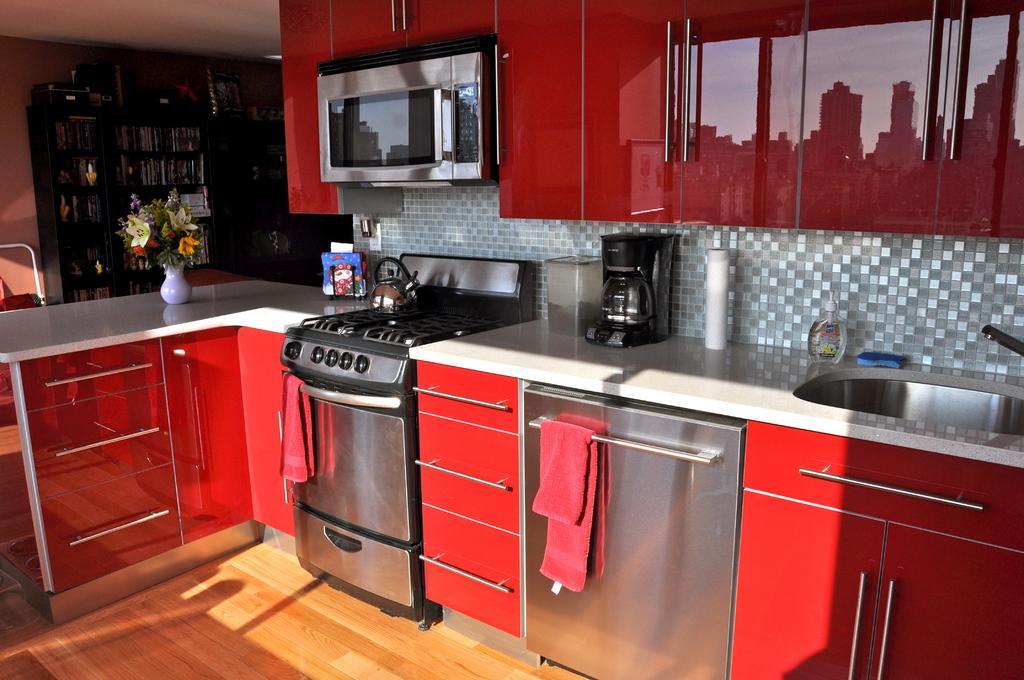Describe this image in one or two sentences. In this image we can see the inside view of the kitchen that includes electronic gadgets, cupboards, wash basin, towels, utensils and flower pot. 